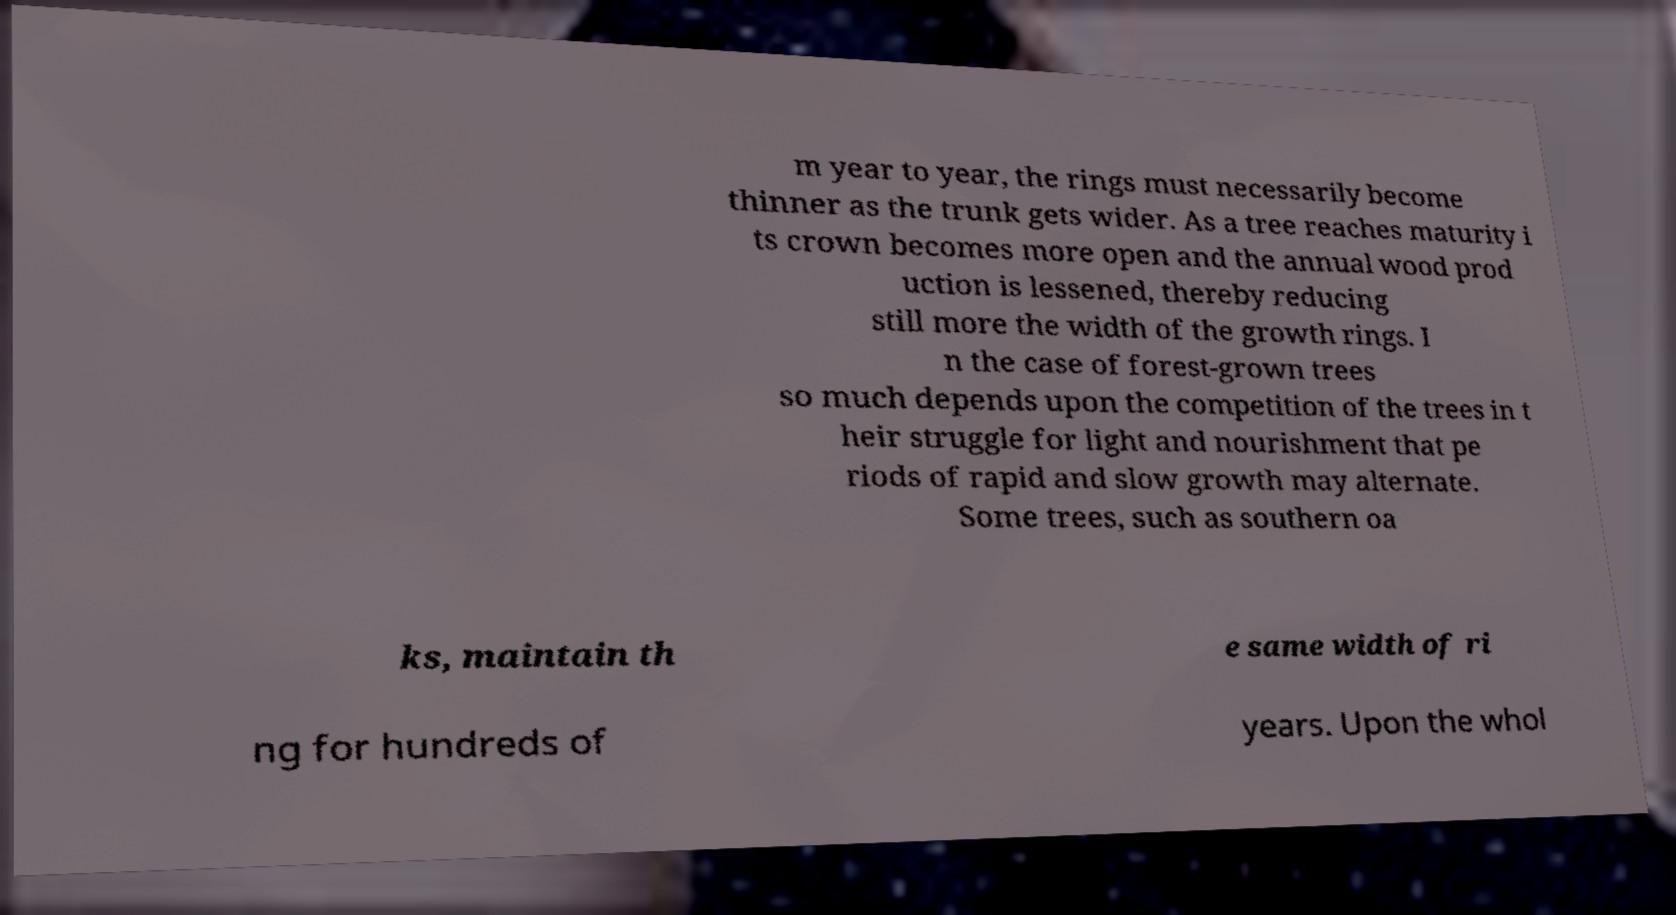Please identify and transcribe the text found in this image. m year to year, the rings must necessarily become thinner as the trunk gets wider. As a tree reaches maturity i ts crown becomes more open and the annual wood prod uction is lessened, thereby reducing still more the width of the growth rings. I n the case of forest-grown trees so much depends upon the competition of the trees in t heir struggle for light and nourishment that pe riods of rapid and slow growth may alternate. Some trees, such as southern oa ks, maintain th e same width of ri ng for hundreds of years. Upon the whol 